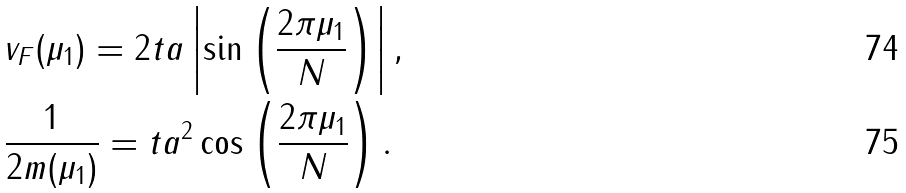<formula> <loc_0><loc_0><loc_500><loc_500>& v _ { F } ( \mu _ { 1 } ) = 2 t a \left | \sin \left ( \frac { 2 \pi \mu _ { 1 } } { N } \right ) \right | , \\ & \frac { 1 } { 2 m ( \mu _ { 1 } ) } = t a ^ { 2 } \cos \left ( \frac { 2 \pi \mu _ { 1 } } { N } \right ) .</formula> 